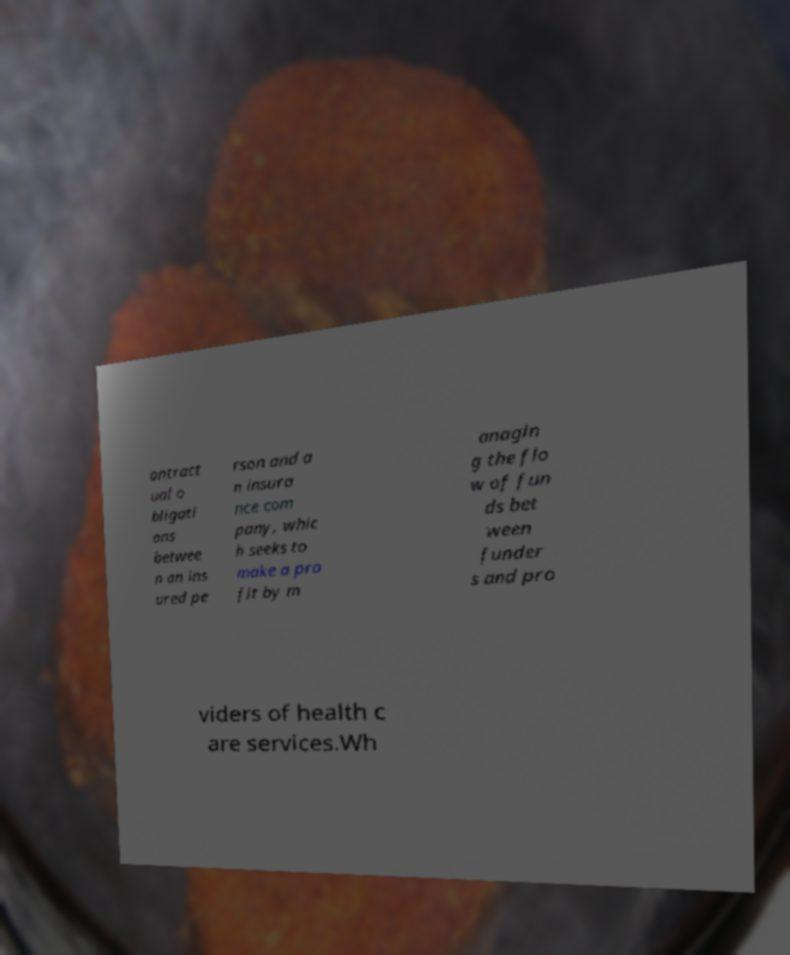Please read and relay the text visible in this image. What does it say? ontract ual o bligati ons betwee n an ins ured pe rson and a n insura nce com pany, whic h seeks to make a pro fit by m anagin g the flo w of fun ds bet ween funder s and pro viders of health c are services.Wh 